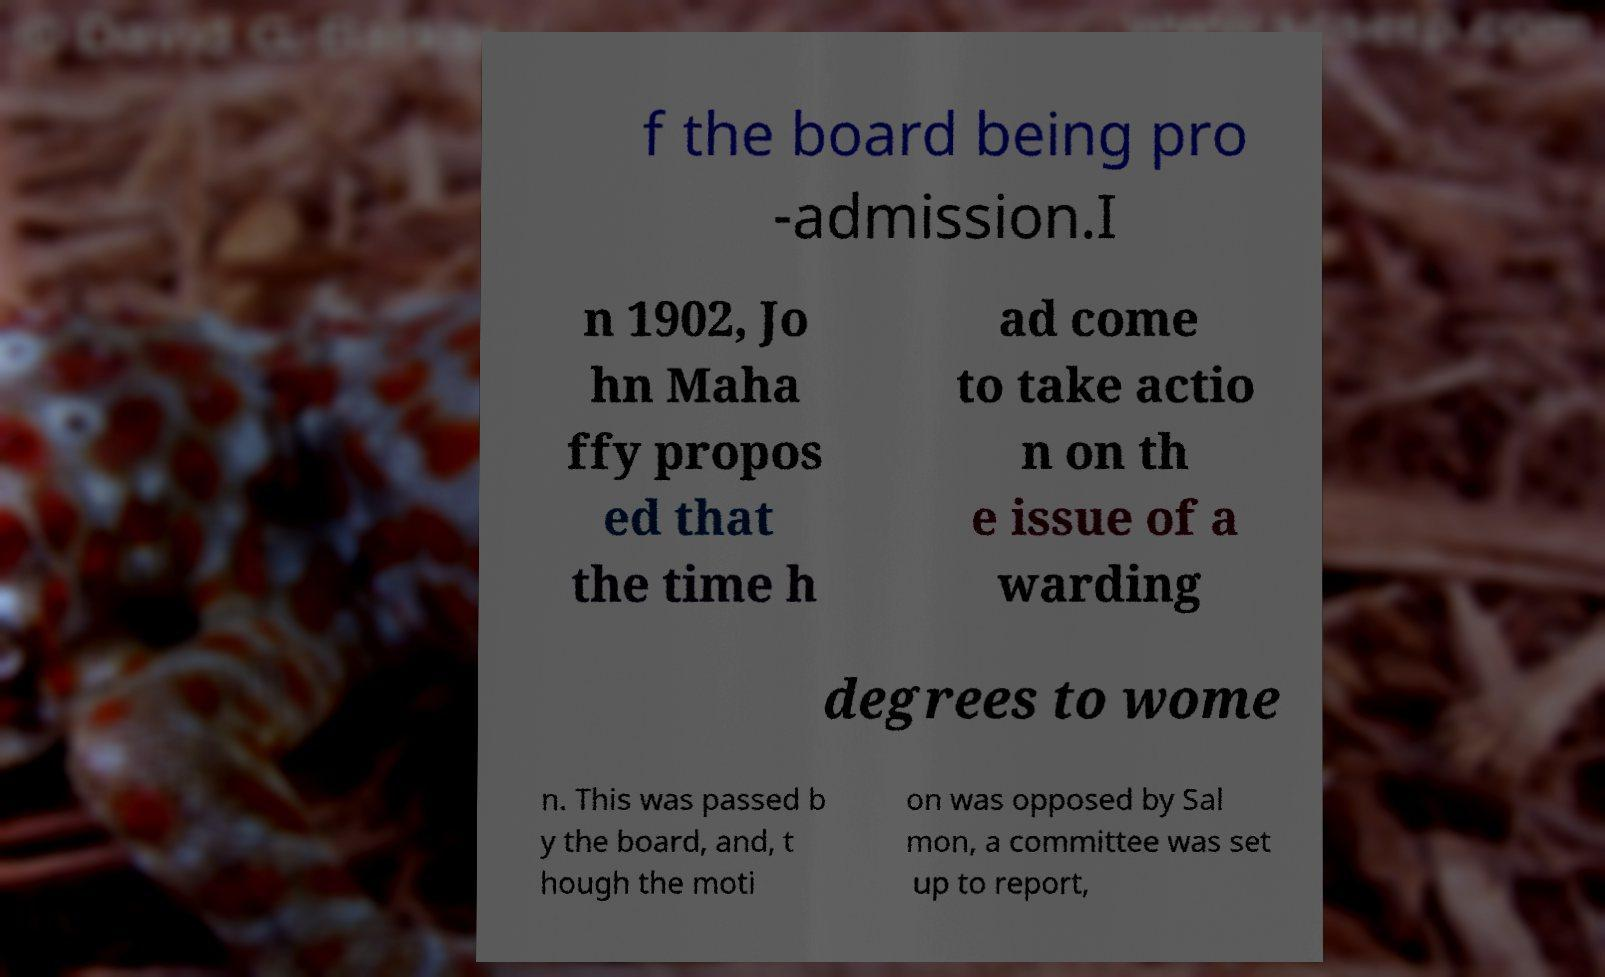Please read and relay the text visible in this image. What does it say? f the board being pro -admission.I n 1902, Jo hn Maha ffy propos ed that the time h ad come to take actio n on th e issue of a warding degrees to wome n. This was passed b y the board, and, t hough the moti on was opposed by Sal mon, a committee was set up to report, 